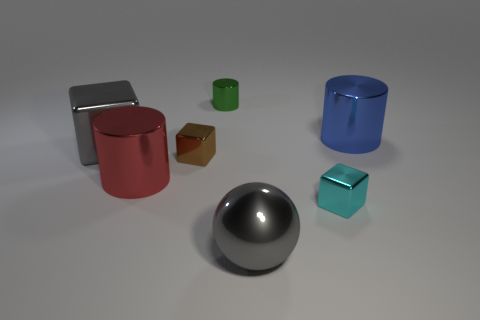Add 3 red metallic objects. How many objects exist? 10 Subtract all cylinders. How many objects are left? 4 Subtract 0 green cubes. How many objects are left? 7 Subtract all green cylinders. Subtract all gray shiny objects. How many objects are left? 4 Add 4 brown metal cubes. How many brown metal cubes are left? 5 Add 4 small yellow spheres. How many small yellow spheres exist? 4 